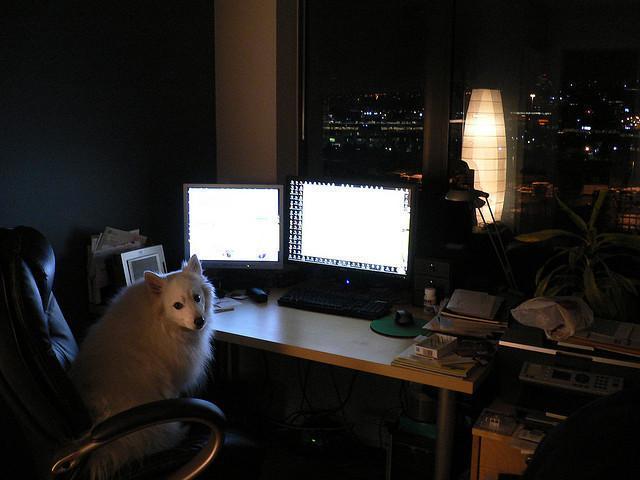How many chairs are visible?
Give a very brief answer. 2. How many tvs are in the photo?
Give a very brief answer. 2. 